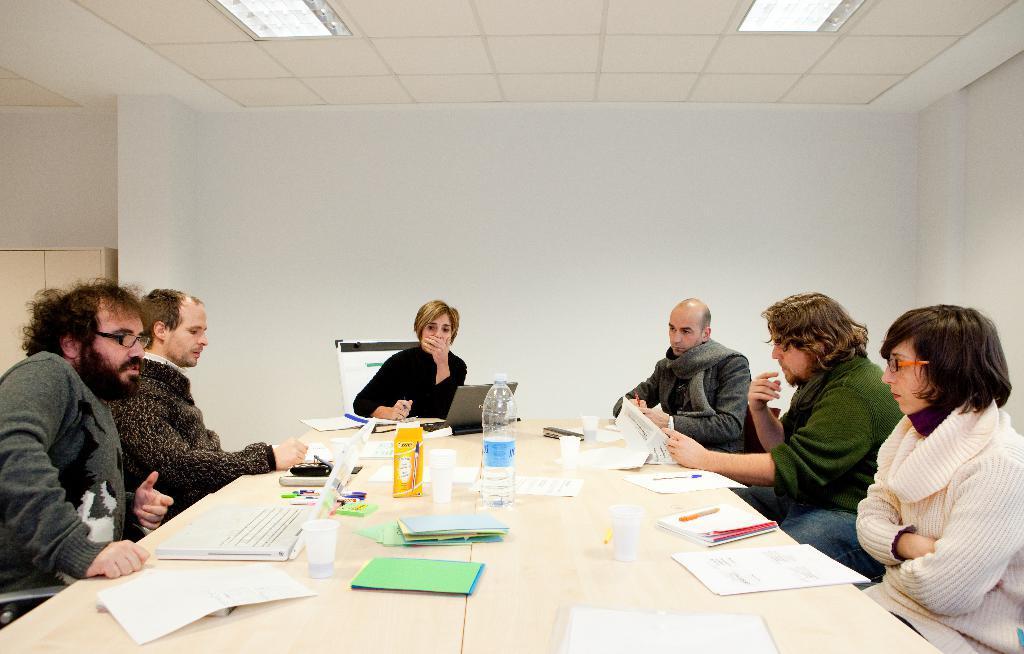Describe this image in one or two sentences. Here we can see six persons are sitting on the chairs. This is table. On the table there are books, papers, laptops, bottle, and glasses. In the background there is a wall. This is roof and these are the lights. 